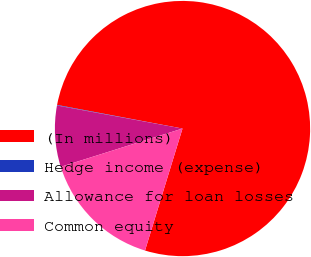<chart> <loc_0><loc_0><loc_500><loc_500><pie_chart><fcel>(In millions)<fcel>Hedge income (expense)<fcel>Allowance for loan losses<fcel>Common equity<nl><fcel>76.79%<fcel>0.07%<fcel>7.74%<fcel>15.41%<nl></chart> 